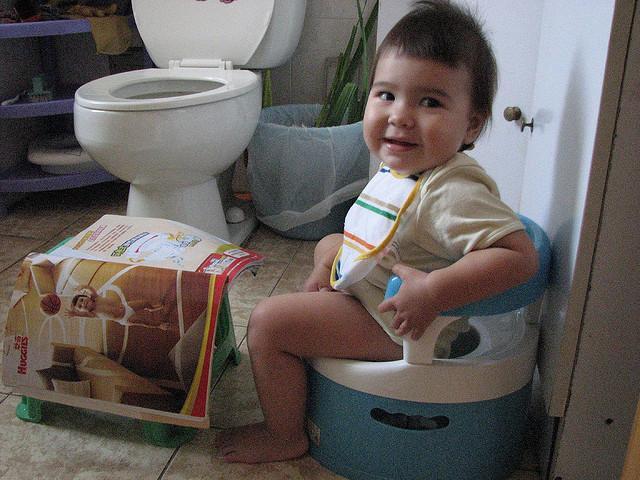How many people are there?
Give a very brief answer. 1. How many toilets can you see?
Give a very brief answer. 2. 